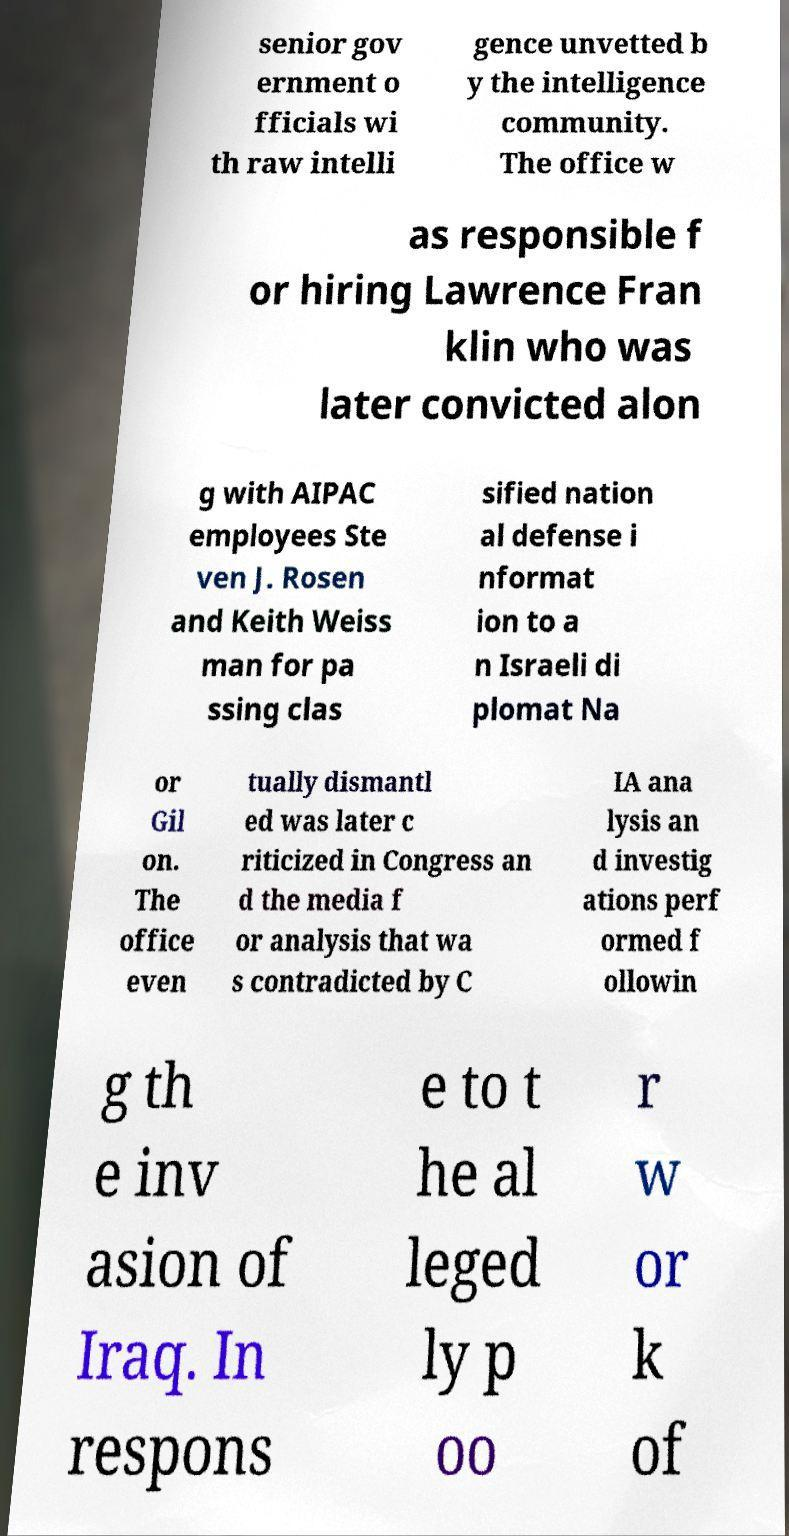Could you extract and type out the text from this image? senior gov ernment o fficials wi th raw intelli gence unvetted b y the intelligence community. The office w as responsible f or hiring Lawrence Fran klin who was later convicted alon g with AIPAC employees Ste ven J. Rosen and Keith Weiss man for pa ssing clas sified nation al defense i nformat ion to a n Israeli di plomat Na or Gil on. The office even tually dismantl ed was later c riticized in Congress an d the media f or analysis that wa s contradicted by C IA ana lysis an d investig ations perf ormed f ollowin g th e inv asion of Iraq. In respons e to t he al leged ly p oo r w or k of 